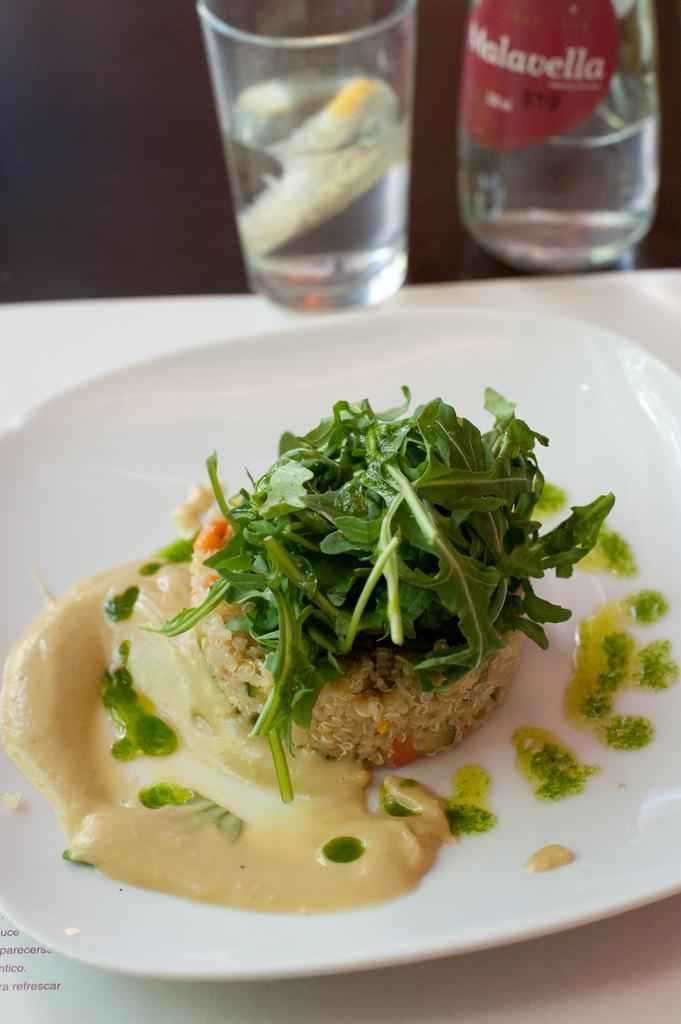Provide a one-sentence caption for the provided image. A restaurant table with a meal and a glass that says Malavella. 